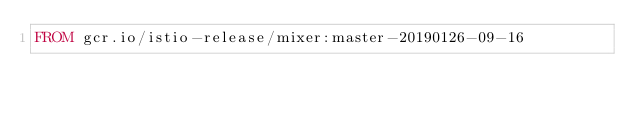Convert code to text. <code><loc_0><loc_0><loc_500><loc_500><_Dockerfile_>FROM gcr.io/istio-release/mixer:master-20190126-09-16
</code> 